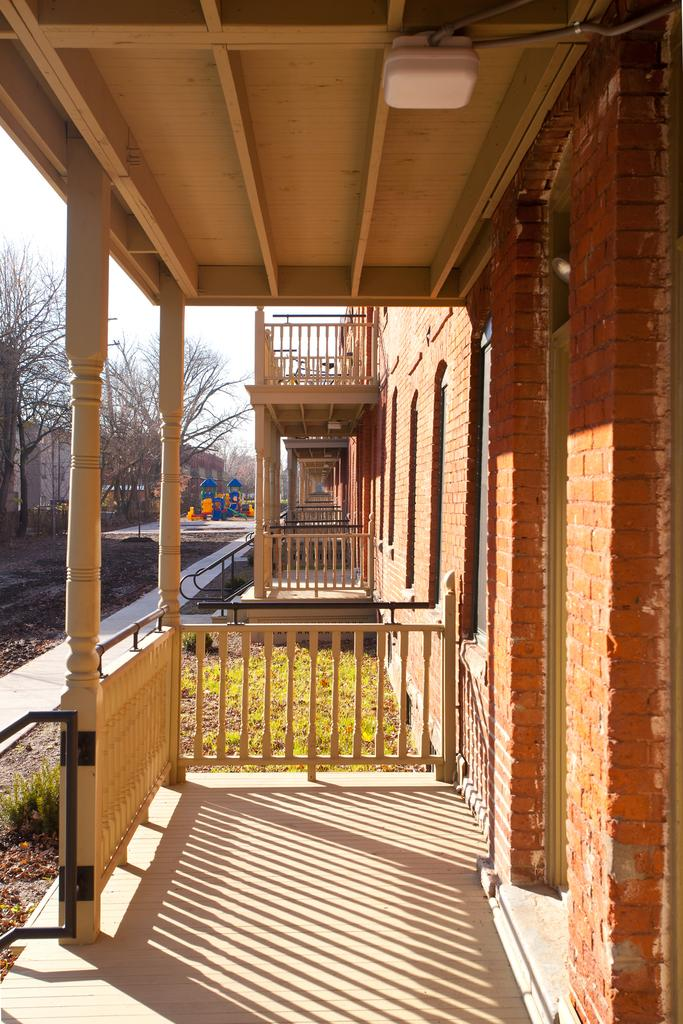What type of structures can be seen in the image? There are buildings in the image. What architectural feature is present in the image? There are railings in the image. What type of vegetation is visible in the image? There is grass and trees in the image. What colors are present in the image? There are blue and orange color objects in the image. What is visible in the background of the image? The sky is visible in the background of the image. What is the color of the white object at the top of the image? The white object at the top of the image is white. Can you see any smoke coming from the buildings in the image? There is no smoke present in the image. What type of cloth is draped over the trees in the image? There is no cloth draped over the trees in the image; only grass, trees, and buildings are present. 